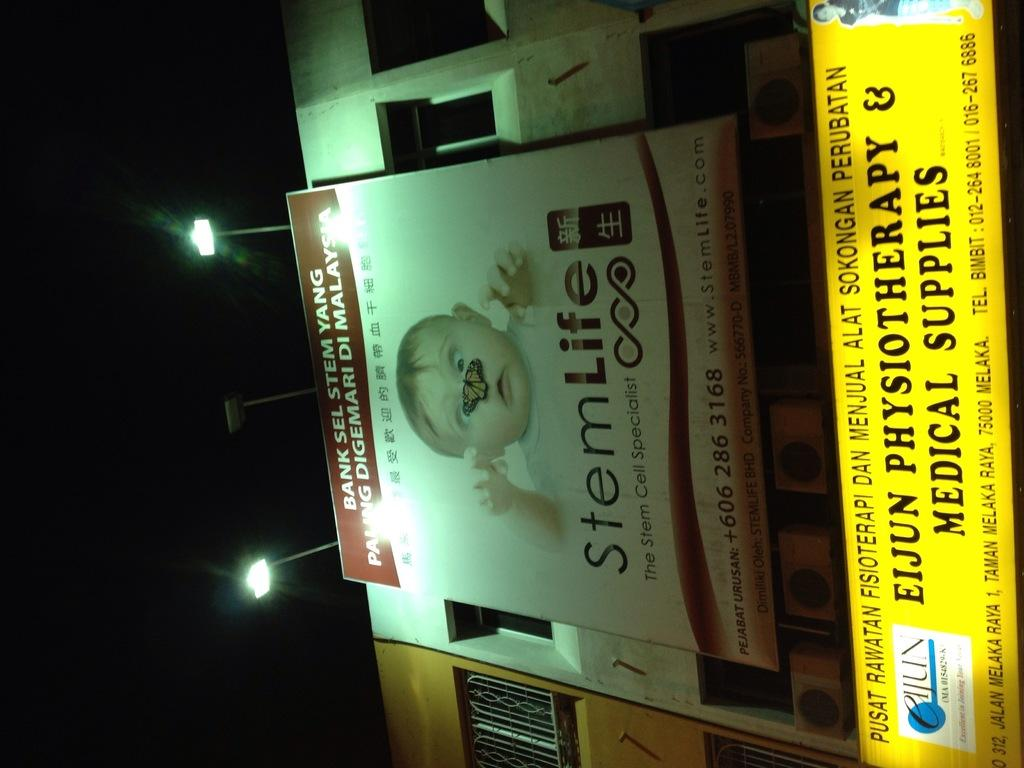<image>
Write a terse but informative summary of the picture. Stemlife poster with a baby by The Stem Cell Specialist. 